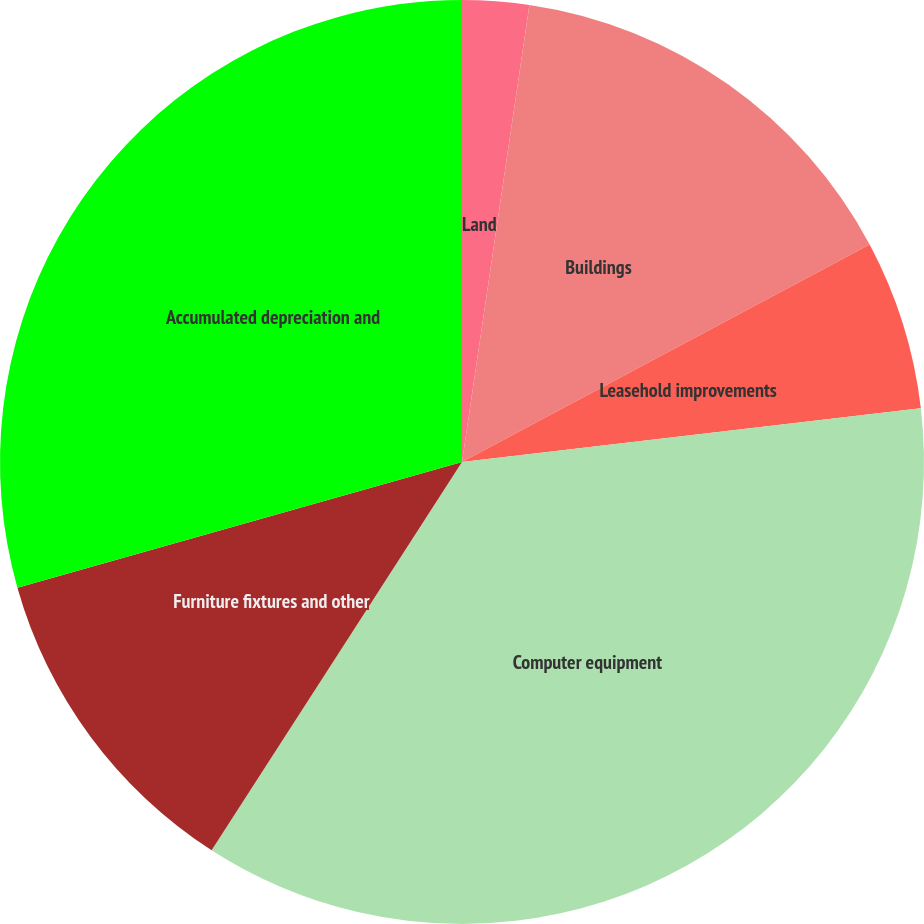<chart> <loc_0><loc_0><loc_500><loc_500><pie_chart><fcel>Land<fcel>Buildings<fcel>Leasehold improvements<fcel>Computer equipment<fcel>Furniture fixtures and other<fcel>Accumulated depreciation and<nl><fcel>2.33%<fcel>14.87%<fcel>5.94%<fcel>35.97%<fcel>11.5%<fcel>29.38%<nl></chart> 